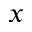Convert formula to latex. <formula><loc_0><loc_0><loc_500><loc_500>_ { x }</formula> 